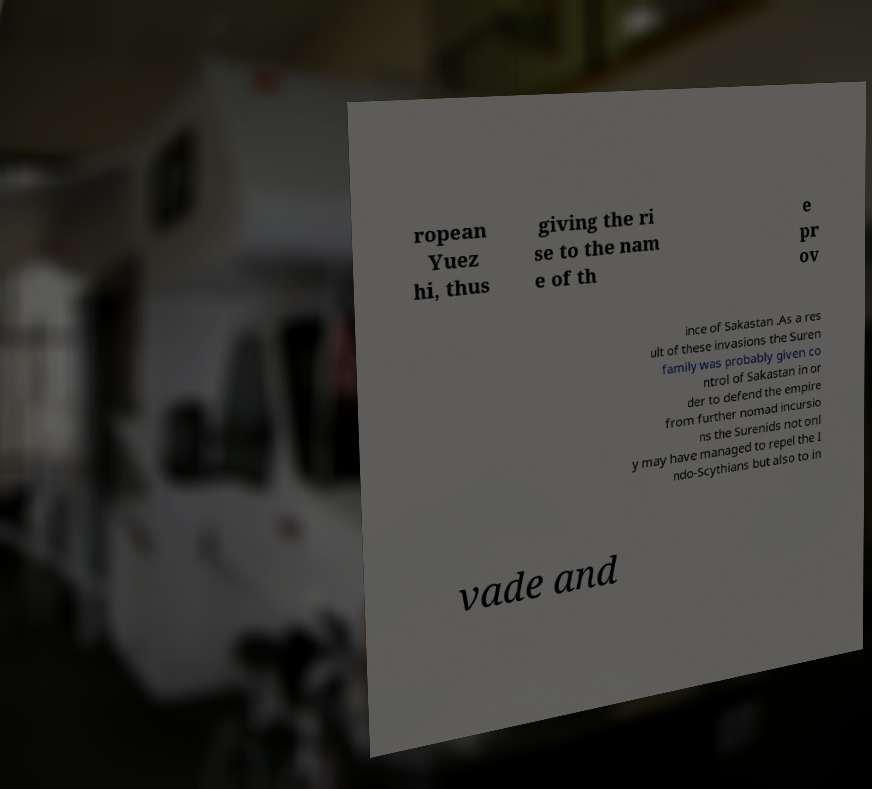Could you extract and type out the text from this image? ropean Yuez hi, thus giving the ri se to the nam e of th e pr ov ince of Sakastan .As a res ult of these invasions the Suren family was probably given co ntrol of Sakastan in or der to defend the empire from further nomad incursio ns the Surenids not onl y may have managed to repel the I ndo-Scythians but also to in vade and 